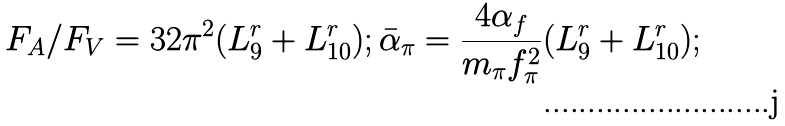<formula> <loc_0><loc_0><loc_500><loc_500>F _ { A } / F _ { V } = 3 2 \pi ^ { 2 } ( L ^ { r } _ { 9 } + L ^ { r } _ { 1 0 } ) ; \bar { \alpha } _ { \pi } = \frac { 4 \alpha _ { f } } { m _ { \pi } f ^ { 2 } _ { \pi } } ( L ^ { r } _ { 9 } + L ^ { r } _ { 1 0 } ) ;</formula> 